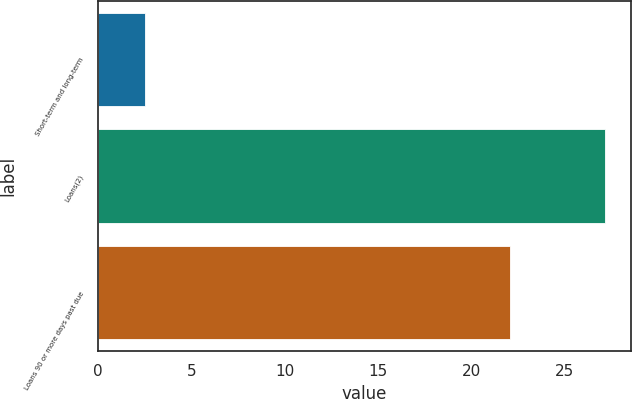Convert chart. <chart><loc_0><loc_0><loc_500><loc_500><bar_chart><fcel>Short-term and long-term<fcel>Loans(2)<fcel>Loans 90 or more days past due<nl><fcel>2.5<fcel>27.2<fcel>22.1<nl></chart> 